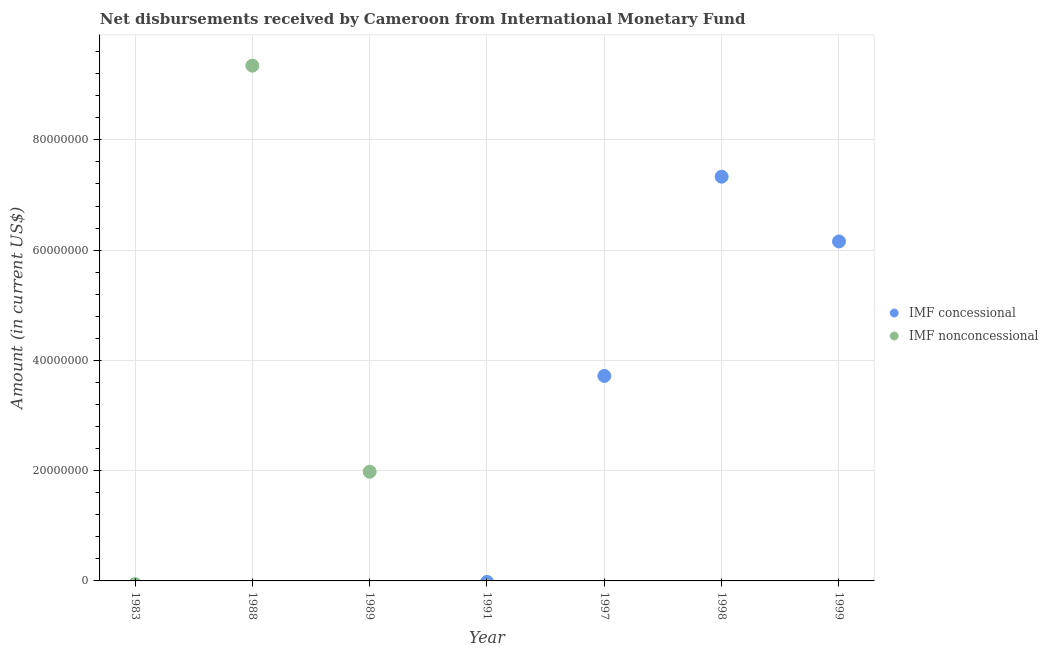What is the net concessional disbursements from imf in 1997?
Ensure brevity in your answer.  3.72e+07. Across all years, what is the maximum net concessional disbursements from imf?
Provide a succinct answer. 7.33e+07. In which year was the net concessional disbursements from imf maximum?
Provide a short and direct response. 1998. What is the total net non concessional disbursements from imf in the graph?
Your response must be concise. 1.13e+08. What is the difference between the net concessional disbursements from imf in 1997 and that in 1998?
Your answer should be very brief. -3.61e+07. What is the difference between the net non concessional disbursements from imf in 1997 and the net concessional disbursements from imf in 1999?
Ensure brevity in your answer.  -6.16e+07. What is the average net non concessional disbursements from imf per year?
Your answer should be very brief. 1.62e+07. In how many years, is the net concessional disbursements from imf greater than 56000000 US$?
Your answer should be very brief. 2. What is the ratio of the net concessional disbursements from imf in 1998 to that in 1999?
Your answer should be very brief. 1.19. What is the difference between the highest and the second highest net concessional disbursements from imf?
Provide a short and direct response. 1.17e+07. What is the difference between the highest and the lowest net non concessional disbursements from imf?
Keep it short and to the point. 9.35e+07. In how many years, is the net non concessional disbursements from imf greater than the average net non concessional disbursements from imf taken over all years?
Make the answer very short. 2. Is the net non concessional disbursements from imf strictly less than the net concessional disbursements from imf over the years?
Make the answer very short. No. What is the difference between two consecutive major ticks on the Y-axis?
Offer a terse response. 2.00e+07. Are the values on the major ticks of Y-axis written in scientific E-notation?
Your answer should be compact. No. Where does the legend appear in the graph?
Your answer should be very brief. Center right. How many legend labels are there?
Your answer should be compact. 2. How are the legend labels stacked?
Provide a short and direct response. Vertical. What is the title of the graph?
Provide a succinct answer. Net disbursements received by Cameroon from International Monetary Fund. Does "Merchandise imports" appear as one of the legend labels in the graph?
Give a very brief answer. No. What is the Amount (in current US$) of IMF nonconcessional in 1983?
Keep it short and to the point. 0. What is the Amount (in current US$) in IMF concessional in 1988?
Keep it short and to the point. 0. What is the Amount (in current US$) of IMF nonconcessional in 1988?
Your answer should be very brief. 9.35e+07. What is the Amount (in current US$) of IMF concessional in 1989?
Make the answer very short. 0. What is the Amount (in current US$) in IMF nonconcessional in 1989?
Offer a terse response. 1.98e+07. What is the Amount (in current US$) in IMF concessional in 1991?
Your response must be concise. 0. What is the Amount (in current US$) in IMF nonconcessional in 1991?
Keep it short and to the point. 0. What is the Amount (in current US$) of IMF concessional in 1997?
Keep it short and to the point. 3.72e+07. What is the Amount (in current US$) of IMF concessional in 1998?
Keep it short and to the point. 7.33e+07. What is the Amount (in current US$) in IMF nonconcessional in 1998?
Provide a short and direct response. 0. What is the Amount (in current US$) in IMF concessional in 1999?
Keep it short and to the point. 6.16e+07. What is the Amount (in current US$) of IMF nonconcessional in 1999?
Make the answer very short. 0. Across all years, what is the maximum Amount (in current US$) in IMF concessional?
Give a very brief answer. 7.33e+07. Across all years, what is the maximum Amount (in current US$) in IMF nonconcessional?
Make the answer very short. 9.35e+07. What is the total Amount (in current US$) in IMF concessional in the graph?
Make the answer very short. 1.72e+08. What is the total Amount (in current US$) in IMF nonconcessional in the graph?
Give a very brief answer. 1.13e+08. What is the difference between the Amount (in current US$) in IMF nonconcessional in 1988 and that in 1989?
Offer a very short reply. 7.37e+07. What is the difference between the Amount (in current US$) of IMF concessional in 1997 and that in 1998?
Offer a very short reply. -3.61e+07. What is the difference between the Amount (in current US$) of IMF concessional in 1997 and that in 1999?
Offer a terse response. -2.44e+07. What is the difference between the Amount (in current US$) of IMF concessional in 1998 and that in 1999?
Ensure brevity in your answer.  1.17e+07. What is the average Amount (in current US$) of IMF concessional per year?
Provide a succinct answer. 2.46e+07. What is the average Amount (in current US$) in IMF nonconcessional per year?
Give a very brief answer. 1.62e+07. What is the ratio of the Amount (in current US$) of IMF nonconcessional in 1988 to that in 1989?
Provide a succinct answer. 4.72. What is the ratio of the Amount (in current US$) in IMF concessional in 1997 to that in 1998?
Keep it short and to the point. 0.51. What is the ratio of the Amount (in current US$) of IMF concessional in 1997 to that in 1999?
Give a very brief answer. 0.6. What is the ratio of the Amount (in current US$) of IMF concessional in 1998 to that in 1999?
Provide a succinct answer. 1.19. What is the difference between the highest and the second highest Amount (in current US$) of IMF concessional?
Make the answer very short. 1.17e+07. What is the difference between the highest and the lowest Amount (in current US$) in IMF concessional?
Make the answer very short. 7.33e+07. What is the difference between the highest and the lowest Amount (in current US$) of IMF nonconcessional?
Ensure brevity in your answer.  9.35e+07. 